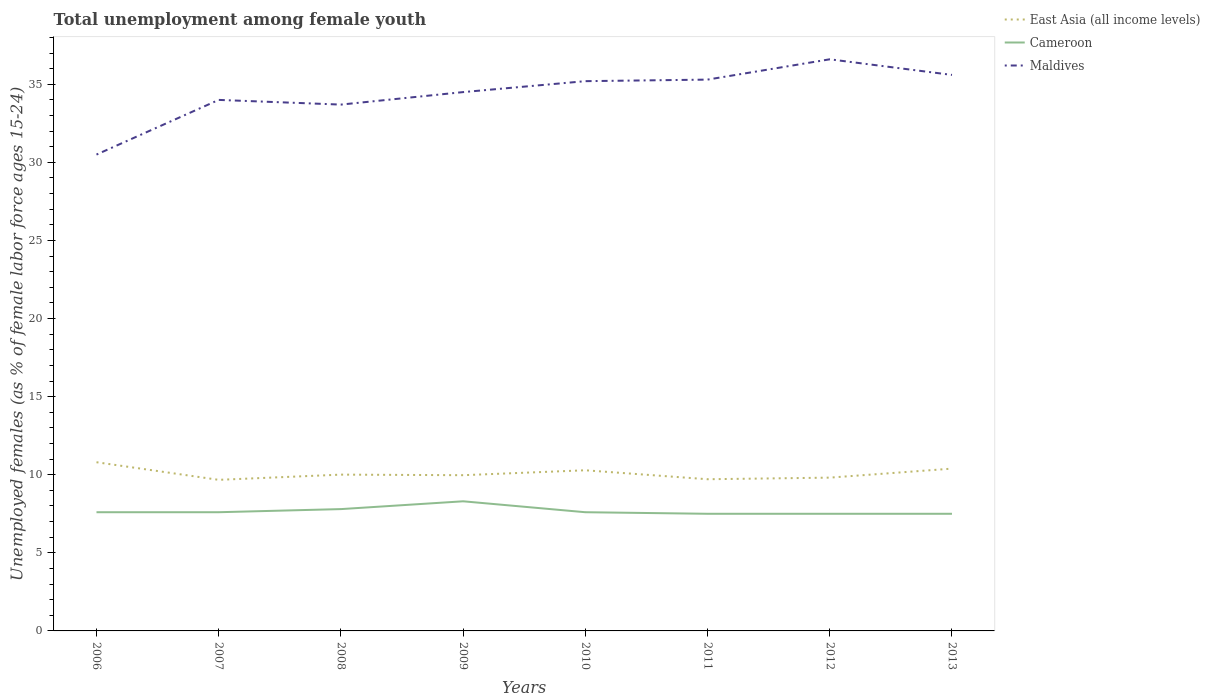How many different coloured lines are there?
Provide a short and direct response. 3. Across all years, what is the maximum percentage of unemployed females in in Cameroon?
Provide a succinct answer. 7.5. What is the total percentage of unemployed females in in Cameroon in the graph?
Offer a very short reply. 0.3. What is the difference between the highest and the second highest percentage of unemployed females in in Cameroon?
Your response must be concise. 0.8. Is the percentage of unemployed females in in Maldives strictly greater than the percentage of unemployed females in in East Asia (all income levels) over the years?
Your answer should be very brief. No. How many years are there in the graph?
Provide a succinct answer. 8. Are the values on the major ticks of Y-axis written in scientific E-notation?
Offer a very short reply. No. Does the graph contain grids?
Your response must be concise. No. Where does the legend appear in the graph?
Your response must be concise. Top right. What is the title of the graph?
Give a very brief answer. Total unemployment among female youth. What is the label or title of the X-axis?
Make the answer very short. Years. What is the label or title of the Y-axis?
Provide a short and direct response. Unemployed females (as % of female labor force ages 15-24). What is the Unemployed females (as % of female labor force ages 15-24) in East Asia (all income levels) in 2006?
Provide a succinct answer. 10.8. What is the Unemployed females (as % of female labor force ages 15-24) in Cameroon in 2006?
Ensure brevity in your answer.  7.6. What is the Unemployed females (as % of female labor force ages 15-24) of Maldives in 2006?
Provide a succinct answer. 30.5. What is the Unemployed females (as % of female labor force ages 15-24) in East Asia (all income levels) in 2007?
Keep it short and to the point. 9.67. What is the Unemployed females (as % of female labor force ages 15-24) of Cameroon in 2007?
Your answer should be very brief. 7.6. What is the Unemployed females (as % of female labor force ages 15-24) in East Asia (all income levels) in 2008?
Make the answer very short. 10.01. What is the Unemployed females (as % of female labor force ages 15-24) of Cameroon in 2008?
Give a very brief answer. 7.8. What is the Unemployed females (as % of female labor force ages 15-24) of Maldives in 2008?
Your response must be concise. 33.7. What is the Unemployed females (as % of female labor force ages 15-24) of East Asia (all income levels) in 2009?
Keep it short and to the point. 9.97. What is the Unemployed females (as % of female labor force ages 15-24) in Cameroon in 2009?
Offer a terse response. 8.3. What is the Unemployed females (as % of female labor force ages 15-24) of Maldives in 2009?
Make the answer very short. 34.5. What is the Unemployed females (as % of female labor force ages 15-24) in East Asia (all income levels) in 2010?
Offer a very short reply. 10.29. What is the Unemployed females (as % of female labor force ages 15-24) in Cameroon in 2010?
Ensure brevity in your answer.  7.6. What is the Unemployed females (as % of female labor force ages 15-24) of Maldives in 2010?
Your response must be concise. 35.2. What is the Unemployed females (as % of female labor force ages 15-24) of East Asia (all income levels) in 2011?
Give a very brief answer. 9.71. What is the Unemployed females (as % of female labor force ages 15-24) of Maldives in 2011?
Provide a short and direct response. 35.3. What is the Unemployed females (as % of female labor force ages 15-24) in East Asia (all income levels) in 2012?
Your response must be concise. 9.81. What is the Unemployed females (as % of female labor force ages 15-24) of Maldives in 2012?
Provide a short and direct response. 36.6. What is the Unemployed females (as % of female labor force ages 15-24) of East Asia (all income levels) in 2013?
Provide a short and direct response. 10.39. What is the Unemployed females (as % of female labor force ages 15-24) in Maldives in 2013?
Offer a very short reply. 35.6. Across all years, what is the maximum Unemployed females (as % of female labor force ages 15-24) of East Asia (all income levels)?
Provide a succinct answer. 10.8. Across all years, what is the maximum Unemployed females (as % of female labor force ages 15-24) of Cameroon?
Ensure brevity in your answer.  8.3. Across all years, what is the maximum Unemployed females (as % of female labor force ages 15-24) in Maldives?
Offer a terse response. 36.6. Across all years, what is the minimum Unemployed females (as % of female labor force ages 15-24) in East Asia (all income levels)?
Offer a very short reply. 9.67. Across all years, what is the minimum Unemployed females (as % of female labor force ages 15-24) in Maldives?
Make the answer very short. 30.5. What is the total Unemployed females (as % of female labor force ages 15-24) of East Asia (all income levels) in the graph?
Your answer should be very brief. 80.66. What is the total Unemployed females (as % of female labor force ages 15-24) of Cameroon in the graph?
Keep it short and to the point. 61.4. What is the total Unemployed females (as % of female labor force ages 15-24) of Maldives in the graph?
Offer a very short reply. 275.4. What is the difference between the Unemployed females (as % of female labor force ages 15-24) of East Asia (all income levels) in 2006 and that in 2007?
Offer a very short reply. 1.13. What is the difference between the Unemployed females (as % of female labor force ages 15-24) in Cameroon in 2006 and that in 2007?
Give a very brief answer. 0. What is the difference between the Unemployed females (as % of female labor force ages 15-24) of Maldives in 2006 and that in 2007?
Offer a terse response. -3.5. What is the difference between the Unemployed females (as % of female labor force ages 15-24) in East Asia (all income levels) in 2006 and that in 2008?
Ensure brevity in your answer.  0.79. What is the difference between the Unemployed females (as % of female labor force ages 15-24) of Cameroon in 2006 and that in 2008?
Provide a short and direct response. -0.2. What is the difference between the Unemployed females (as % of female labor force ages 15-24) of East Asia (all income levels) in 2006 and that in 2009?
Your response must be concise. 0.83. What is the difference between the Unemployed females (as % of female labor force ages 15-24) of Cameroon in 2006 and that in 2009?
Keep it short and to the point. -0.7. What is the difference between the Unemployed females (as % of female labor force ages 15-24) in Maldives in 2006 and that in 2009?
Ensure brevity in your answer.  -4. What is the difference between the Unemployed females (as % of female labor force ages 15-24) of East Asia (all income levels) in 2006 and that in 2010?
Your answer should be very brief. 0.51. What is the difference between the Unemployed females (as % of female labor force ages 15-24) of East Asia (all income levels) in 2006 and that in 2011?
Ensure brevity in your answer.  1.09. What is the difference between the Unemployed females (as % of female labor force ages 15-24) in Cameroon in 2006 and that in 2011?
Ensure brevity in your answer.  0.1. What is the difference between the Unemployed females (as % of female labor force ages 15-24) of Maldives in 2006 and that in 2011?
Offer a terse response. -4.8. What is the difference between the Unemployed females (as % of female labor force ages 15-24) of Cameroon in 2006 and that in 2012?
Provide a succinct answer. 0.1. What is the difference between the Unemployed females (as % of female labor force ages 15-24) of Maldives in 2006 and that in 2012?
Offer a very short reply. -6.1. What is the difference between the Unemployed females (as % of female labor force ages 15-24) of East Asia (all income levels) in 2006 and that in 2013?
Make the answer very short. 0.41. What is the difference between the Unemployed females (as % of female labor force ages 15-24) in Cameroon in 2006 and that in 2013?
Make the answer very short. 0.1. What is the difference between the Unemployed females (as % of female labor force ages 15-24) in East Asia (all income levels) in 2007 and that in 2008?
Offer a very short reply. -0.33. What is the difference between the Unemployed females (as % of female labor force ages 15-24) of Maldives in 2007 and that in 2008?
Provide a succinct answer. 0.3. What is the difference between the Unemployed females (as % of female labor force ages 15-24) of East Asia (all income levels) in 2007 and that in 2009?
Give a very brief answer. -0.3. What is the difference between the Unemployed females (as % of female labor force ages 15-24) in Cameroon in 2007 and that in 2009?
Ensure brevity in your answer.  -0.7. What is the difference between the Unemployed females (as % of female labor force ages 15-24) of East Asia (all income levels) in 2007 and that in 2010?
Make the answer very short. -0.61. What is the difference between the Unemployed females (as % of female labor force ages 15-24) of Cameroon in 2007 and that in 2010?
Offer a very short reply. 0. What is the difference between the Unemployed females (as % of female labor force ages 15-24) of Maldives in 2007 and that in 2010?
Make the answer very short. -1.2. What is the difference between the Unemployed females (as % of female labor force ages 15-24) of East Asia (all income levels) in 2007 and that in 2011?
Provide a short and direct response. -0.04. What is the difference between the Unemployed females (as % of female labor force ages 15-24) in Cameroon in 2007 and that in 2011?
Give a very brief answer. 0.1. What is the difference between the Unemployed females (as % of female labor force ages 15-24) in East Asia (all income levels) in 2007 and that in 2012?
Offer a very short reply. -0.14. What is the difference between the Unemployed females (as % of female labor force ages 15-24) of Maldives in 2007 and that in 2012?
Your answer should be compact. -2.6. What is the difference between the Unemployed females (as % of female labor force ages 15-24) of East Asia (all income levels) in 2007 and that in 2013?
Ensure brevity in your answer.  -0.72. What is the difference between the Unemployed females (as % of female labor force ages 15-24) in Maldives in 2007 and that in 2013?
Your answer should be very brief. -1.6. What is the difference between the Unemployed females (as % of female labor force ages 15-24) of East Asia (all income levels) in 2008 and that in 2009?
Make the answer very short. 0.04. What is the difference between the Unemployed females (as % of female labor force ages 15-24) in Maldives in 2008 and that in 2009?
Give a very brief answer. -0.8. What is the difference between the Unemployed females (as % of female labor force ages 15-24) in East Asia (all income levels) in 2008 and that in 2010?
Your answer should be compact. -0.28. What is the difference between the Unemployed females (as % of female labor force ages 15-24) of East Asia (all income levels) in 2008 and that in 2011?
Make the answer very short. 0.3. What is the difference between the Unemployed females (as % of female labor force ages 15-24) of Maldives in 2008 and that in 2011?
Your answer should be compact. -1.6. What is the difference between the Unemployed females (as % of female labor force ages 15-24) of East Asia (all income levels) in 2008 and that in 2012?
Provide a succinct answer. 0.19. What is the difference between the Unemployed females (as % of female labor force ages 15-24) of Cameroon in 2008 and that in 2012?
Offer a very short reply. 0.3. What is the difference between the Unemployed females (as % of female labor force ages 15-24) of Maldives in 2008 and that in 2012?
Ensure brevity in your answer.  -2.9. What is the difference between the Unemployed females (as % of female labor force ages 15-24) in East Asia (all income levels) in 2008 and that in 2013?
Keep it short and to the point. -0.38. What is the difference between the Unemployed females (as % of female labor force ages 15-24) of East Asia (all income levels) in 2009 and that in 2010?
Keep it short and to the point. -0.32. What is the difference between the Unemployed females (as % of female labor force ages 15-24) of Cameroon in 2009 and that in 2010?
Your answer should be very brief. 0.7. What is the difference between the Unemployed females (as % of female labor force ages 15-24) of East Asia (all income levels) in 2009 and that in 2011?
Ensure brevity in your answer.  0.26. What is the difference between the Unemployed females (as % of female labor force ages 15-24) of Maldives in 2009 and that in 2011?
Ensure brevity in your answer.  -0.8. What is the difference between the Unemployed females (as % of female labor force ages 15-24) in East Asia (all income levels) in 2009 and that in 2012?
Your answer should be very brief. 0.16. What is the difference between the Unemployed females (as % of female labor force ages 15-24) of Cameroon in 2009 and that in 2012?
Provide a succinct answer. 0.8. What is the difference between the Unemployed females (as % of female labor force ages 15-24) in East Asia (all income levels) in 2009 and that in 2013?
Keep it short and to the point. -0.42. What is the difference between the Unemployed females (as % of female labor force ages 15-24) of Cameroon in 2009 and that in 2013?
Your answer should be compact. 0.8. What is the difference between the Unemployed females (as % of female labor force ages 15-24) in East Asia (all income levels) in 2010 and that in 2011?
Provide a short and direct response. 0.57. What is the difference between the Unemployed females (as % of female labor force ages 15-24) of Cameroon in 2010 and that in 2011?
Your answer should be compact. 0.1. What is the difference between the Unemployed females (as % of female labor force ages 15-24) of Maldives in 2010 and that in 2011?
Your response must be concise. -0.1. What is the difference between the Unemployed females (as % of female labor force ages 15-24) of East Asia (all income levels) in 2010 and that in 2012?
Provide a succinct answer. 0.47. What is the difference between the Unemployed females (as % of female labor force ages 15-24) in Cameroon in 2010 and that in 2012?
Offer a terse response. 0.1. What is the difference between the Unemployed females (as % of female labor force ages 15-24) in Maldives in 2010 and that in 2012?
Ensure brevity in your answer.  -1.4. What is the difference between the Unemployed females (as % of female labor force ages 15-24) of East Asia (all income levels) in 2010 and that in 2013?
Your answer should be compact. -0.11. What is the difference between the Unemployed females (as % of female labor force ages 15-24) of Cameroon in 2010 and that in 2013?
Your answer should be very brief. 0.1. What is the difference between the Unemployed females (as % of female labor force ages 15-24) in Maldives in 2010 and that in 2013?
Give a very brief answer. -0.4. What is the difference between the Unemployed females (as % of female labor force ages 15-24) in East Asia (all income levels) in 2011 and that in 2012?
Make the answer very short. -0.1. What is the difference between the Unemployed females (as % of female labor force ages 15-24) in Cameroon in 2011 and that in 2012?
Your answer should be compact. 0. What is the difference between the Unemployed females (as % of female labor force ages 15-24) in East Asia (all income levels) in 2011 and that in 2013?
Provide a succinct answer. -0.68. What is the difference between the Unemployed females (as % of female labor force ages 15-24) of East Asia (all income levels) in 2012 and that in 2013?
Provide a short and direct response. -0.58. What is the difference between the Unemployed females (as % of female labor force ages 15-24) in Cameroon in 2012 and that in 2013?
Ensure brevity in your answer.  0. What is the difference between the Unemployed females (as % of female labor force ages 15-24) of Maldives in 2012 and that in 2013?
Give a very brief answer. 1. What is the difference between the Unemployed females (as % of female labor force ages 15-24) in East Asia (all income levels) in 2006 and the Unemployed females (as % of female labor force ages 15-24) in Cameroon in 2007?
Ensure brevity in your answer.  3.2. What is the difference between the Unemployed females (as % of female labor force ages 15-24) in East Asia (all income levels) in 2006 and the Unemployed females (as % of female labor force ages 15-24) in Maldives in 2007?
Provide a succinct answer. -23.2. What is the difference between the Unemployed females (as % of female labor force ages 15-24) of Cameroon in 2006 and the Unemployed females (as % of female labor force ages 15-24) of Maldives in 2007?
Make the answer very short. -26.4. What is the difference between the Unemployed females (as % of female labor force ages 15-24) of East Asia (all income levels) in 2006 and the Unemployed females (as % of female labor force ages 15-24) of Cameroon in 2008?
Provide a succinct answer. 3. What is the difference between the Unemployed females (as % of female labor force ages 15-24) of East Asia (all income levels) in 2006 and the Unemployed females (as % of female labor force ages 15-24) of Maldives in 2008?
Provide a short and direct response. -22.9. What is the difference between the Unemployed females (as % of female labor force ages 15-24) of Cameroon in 2006 and the Unemployed females (as % of female labor force ages 15-24) of Maldives in 2008?
Your answer should be compact. -26.1. What is the difference between the Unemployed females (as % of female labor force ages 15-24) of East Asia (all income levels) in 2006 and the Unemployed females (as % of female labor force ages 15-24) of Cameroon in 2009?
Make the answer very short. 2.5. What is the difference between the Unemployed females (as % of female labor force ages 15-24) in East Asia (all income levels) in 2006 and the Unemployed females (as % of female labor force ages 15-24) in Maldives in 2009?
Your response must be concise. -23.7. What is the difference between the Unemployed females (as % of female labor force ages 15-24) in Cameroon in 2006 and the Unemployed females (as % of female labor force ages 15-24) in Maldives in 2009?
Provide a short and direct response. -26.9. What is the difference between the Unemployed females (as % of female labor force ages 15-24) in East Asia (all income levels) in 2006 and the Unemployed females (as % of female labor force ages 15-24) in Cameroon in 2010?
Keep it short and to the point. 3.2. What is the difference between the Unemployed females (as % of female labor force ages 15-24) in East Asia (all income levels) in 2006 and the Unemployed females (as % of female labor force ages 15-24) in Maldives in 2010?
Give a very brief answer. -24.4. What is the difference between the Unemployed females (as % of female labor force ages 15-24) in Cameroon in 2006 and the Unemployed females (as % of female labor force ages 15-24) in Maldives in 2010?
Provide a succinct answer. -27.6. What is the difference between the Unemployed females (as % of female labor force ages 15-24) of East Asia (all income levels) in 2006 and the Unemployed females (as % of female labor force ages 15-24) of Cameroon in 2011?
Give a very brief answer. 3.3. What is the difference between the Unemployed females (as % of female labor force ages 15-24) in East Asia (all income levels) in 2006 and the Unemployed females (as % of female labor force ages 15-24) in Maldives in 2011?
Your response must be concise. -24.5. What is the difference between the Unemployed females (as % of female labor force ages 15-24) of Cameroon in 2006 and the Unemployed females (as % of female labor force ages 15-24) of Maldives in 2011?
Offer a terse response. -27.7. What is the difference between the Unemployed females (as % of female labor force ages 15-24) in East Asia (all income levels) in 2006 and the Unemployed females (as % of female labor force ages 15-24) in Cameroon in 2012?
Ensure brevity in your answer.  3.3. What is the difference between the Unemployed females (as % of female labor force ages 15-24) in East Asia (all income levels) in 2006 and the Unemployed females (as % of female labor force ages 15-24) in Maldives in 2012?
Your response must be concise. -25.8. What is the difference between the Unemployed females (as % of female labor force ages 15-24) in Cameroon in 2006 and the Unemployed females (as % of female labor force ages 15-24) in Maldives in 2012?
Your response must be concise. -29. What is the difference between the Unemployed females (as % of female labor force ages 15-24) in East Asia (all income levels) in 2006 and the Unemployed females (as % of female labor force ages 15-24) in Cameroon in 2013?
Provide a succinct answer. 3.3. What is the difference between the Unemployed females (as % of female labor force ages 15-24) of East Asia (all income levels) in 2006 and the Unemployed females (as % of female labor force ages 15-24) of Maldives in 2013?
Your answer should be compact. -24.8. What is the difference between the Unemployed females (as % of female labor force ages 15-24) in Cameroon in 2006 and the Unemployed females (as % of female labor force ages 15-24) in Maldives in 2013?
Offer a terse response. -28. What is the difference between the Unemployed females (as % of female labor force ages 15-24) of East Asia (all income levels) in 2007 and the Unemployed females (as % of female labor force ages 15-24) of Cameroon in 2008?
Offer a terse response. 1.87. What is the difference between the Unemployed females (as % of female labor force ages 15-24) of East Asia (all income levels) in 2007 and the Unemployed females (as % of female labor force ages 15-24) of Maldives in 2008?
Your answer should be very brief. -24.03. What is the difference between the Unemployed females (as % of female labor force ages 15-24) of Cameroon in 2007 and the Unemployed females (as % of female labor force ages 15-24) of Maldives in 2008?
Offer a very short reply. -26.1. What is the difference between the Unemployed females (as % of female labor force ages 15-24) of East Asia (all income levels) in 2007 and the Unemployed females (as % of female labor force ages 15-24) of Cameroon in 2009?
Offer a very short reply. 1.37. What is the difference between the Unemployed females (as % of female labor force ages 15-24) of East Asia (all income levels) in 2007 and the Unemployed females (as % of female labor force ages 15-24) of Maldives in 2009?
Give a very brief answer. -24.83. What is the difference between the Unemployed females (as % of female labor force ages 15-24) in Cameroon in 2007 and the Unemployed females (as % of female labor force ages 15-24) in Maldives in 2009?
Keep it short and to the point. -26.9. What is the difference between the Unemployed females (as % of female labor force ages 15-24) in East Asia (all income levels) in 2007 and the Unemployed females (as % of female labor force ages 15-24) in Cameroon in 2010?
Keep it short and to the point. 2.07. What is the difference between the Unemployed females (as % of female labor force ages 15-24) of East Asia (all income levels) in 2007 and the Unemployed females (as % of female labor force ages 15-24) of Maldives in 2010?
Make the answer very short. -25.53. What is the difference between the Unemployed females (as % of female labor force ages 15-24) of Cameroon in 2007 and the Unemployed females (as % of female labor force ages 15-24) of Maldives in 2010?
Your answer should be very brief. -27.6. What is the difference between the Unemployed females (as % of female labor force ages 15-24) of East Asia (all income levels) in 2007 and the Unemployed females (as % of female labor force ages 15-24) of Cameroon in 2011?
Your response must be concise. 2.17. What is the difference between the Unemployed females (as % of female labor force ages 15-24) in East Asia (all income levels) in 2007 and the Unemployed females (as % of female labor force ages 15-24) in Maldives in 2011?
Your response must be concise. -25.63. What is the difference between the Unemployed females (as % of female labor force ages 15-24) in Cameroon in 2007 and the Unemployed females (as % of female labor force ages 15-24) in Maldives in 2011?
Your answer should be very brief. -27.7. What is the difference between the Unemployed females (as % of female labor force ages 15-24) of East Asia (all income levels) in 2007 and the Unemployed females (as % of female labor force ages 15-24) of Cameroon in 2012?
Provide a succinct answer. 2.17. What is the difference between the Unemployed females (as % of female labor force ages 15-24) of East Asia (all income levels) in 2007 and the Unemployed females (as % of female labor force ages 15-24) of Maldives in 2012?
Offer a very short reply. -26.93. What is the difference between the Unemployed females (as % of female labor force ages 15-24) in Cameroon in 2007 and the Unemployed females (as % of female labor force ages 15-24) in Maldives in 2012?
Make the answer very short. -29. What is the difference between the Unemployed females (as % of female labor force ages 15-24) of East Asia (all income levels) in 2007 and the Unemployed females (as % of female labor force ages 15-24) of Cameroon in 2013?
Provide a short and direct response. 2.17. What is the difference between the Unemployed females (as % of female labor force ages 15-24) of East Asia (all income levels) in 2007 and the Unemployed females (as % of female labor force ages 15-24) of Maldives in 2013?
Offer a very short reply. -25.93. What is the difference between the Unemployed females (as % of female labor force ages 15-24) in East Asia (all income levels) in 2008 and the Unemployed females (as % of female labor force ages 15-24) in Cameroon in 2009?
Offer a very short reply. 1.71. What is the difference between the Unemployed females (as % of female labor force ages 15-24) in East Asia (all income levels) in 2008 and the Unemployed females (as % of female labor force ages 15-24) in Maldives in 2009?
Your answer should be very brief. -24.49. What is the difference between the Unemployed females (as % of female labor force ages 15-24) in Cameroon in 2008 and the Unemployed females (as % of female labor force ages 15-24) in Maldives in 2009?
Offer a terse response. -26.7. What is the difference between the Unemployed females (as % of female labor force ages 15-24) in East Asia (all income levels) in 2008 and the Unemployed females (as % of female labor force ages 15-24) in Cameroon in 2010?
Provide a short and direct response. 2.41. What is the difference between the Unemployed females (as % of female labor force ages 15-24) in East Asia (all income levels) in 2008 and the Unemployed females (as % of female labor force ages 15-24) in Maldives in 2010?
Your answer should be compact. -25.19. What is the difference between the Unemployed females (as % of female labor force ages 15-24) of Cameroon in 2008 and the Unemployed females (as % of female labor force ages 15-24) of Maldives in 2010?
Provide a short and direct response. -27.4. What is the difference between the Unemployed females (as % of female labor force ages 15-24) in East Asia (all income levels) in 2008 and the Unemployed females (as % of female labor force ages 15-24) in Cameroon in 2011?
Provide a short and direct response. 2.51. What is the difference between the Unemployed females (as % of female labor force ages 15-24) of East Asia (all income levels) in 2008 and the Unemployed females (as % of female labor force ages 15-24) of Maldives in 2011?
Provide a succinct answer. -25.29. What is the difference between the Unemployed females (as % of female labor force ages 15-24) in Cameroon in 2008 and the Unemployed females (as % of female labor force ages 15-24) in Maldives in 2011?
Make the answer very short. -27.5. What is the difference between the Unemployed females (as % of female labor force ages 15-24) of East Asia (all income levels) in 2008 and the Unemployed females (as % of female labor force ages 15-24) of Cameroon in 2012?
Provide a short and direct response. 2.51. What is the difference between the Unemployed females (as % of female labor force ages 15-24) in East Asia (all income levels) in 2008 and the Unemployed females (as % of female labor force ages 15-24) in Maldives in 2012?
Your answer should be compact. -26.59. What is the difference between the Unemployed females (as % of female labor force ages 15-24) in Cameroon in 2008 and the Unemployed females (as % of female labor force ages 15-24) in Maldives in 2012?
Provide a short and direct response. -28.8. What is the difference between the Unemployed females (as % of female labor force ages 15-24) in East Asia (all income levels) in 2008 and the Unemployed females (as % of female labor force ages 15-24) in Cameroon in 2013?
Keep it short and to the point. 2.51. What is the difference between the Unemployed females (as % of female labor force ages 15-24) of East Asia (all income levels) in 2008 and the Unemployed females (as % of female labor force ages 15-24) of Maldives in 2013?
Your answer should be compact. -25.59. What is the difference between the Unemployed females (as % of female labor force ages 15-24) of Cameroon in 2008 and the Unemployed females (as % of female labor force ages 15-24) of Maldives in 2013?
Provide a succinct answer. -27.8. What is the difference between the Unemployed females (as % of female labor force ages 15-24) of East Asia (all income levels) in 2009 and the Unemployed females (as % of female labor force ages 15-24) of Cameroon in 2010?
Your answer should be very brief. 2.37. What is the difference between the Unemployed females (as % of female labor force ages 15-24) of East Asia (all income levels) in 2009 and the Unemployed females (as % of female labor force ages 15-24) of Maldives in 2010?
Give a very brief answer. -25.23. What is the difference between the Unemployed females (as % of female labor force ages 15-24) of Cameroon in 2009 and the Unemployed females (as % of female labor force ages 15-24) of Maldives in 2010?
Provide a succinct answer. -26.9. What is the difference between the Unemployed females (as % of female labor force ages 15-24) in East Asia (all income levels) in 2009 and the Unemployed females (as % of female labor force ages 15-24) in Cameroon in 2011?
Make the answer very short. 2.47. What is the difference between the Unemployed females (as % of female labor force ages 15-24) in East Asia (all income levels) in 2009 and the Unemployed females (as % of female labor force ages 15-24) in Maldives in 2011?
Make the answer very short. -25.33. What is the difference between the Unemployed females (as % of female labor force ages 15-24) in East Asia (all income levels) in 2009 and the Unemployed females (as % of female labor force ages 15-24) in Cameroon in 2012?
Keep it short and to the point. 2.47. What is the difference between the Unemployed females (as % of female labor force ages 15-24) in East Asia (all income levels) in 2009 and the Unemployed females (as % of female labor force ages 15-24) in Maldives in 2012?
Make the answer very short. -26.63. What is the difference between the Unemployed females (as % of female labor force ages 15-24) in Cameroon in 2009 and the Unemployed females (as % of female labor force ages 15-24) in Maldives in 2012?
Offer a terse response. -28.3. What is the difference between the Unemployed females (as % of female labor force ages 15-24) in East Asia (all income levels) in 2009 and the Unemployed females (as % of female labor force ages 15-24) in Cameroon in 2013?
Your answer should be compact. 2.47. What is the difference between the Unemployed females (as % of female labor force ages 15-24) in East Asia (all income levels) in 2009 and the Unemployed females (as % of female labor force ages 15-24) in Maldives in 2013?
Provide a succinct answer. -25.63. What is the difference between the Unemployed females (as % of female labor force ages 15-24) in Cameroon in 2009 and the Unemployed females (as % of female labor force ages 15-24) in Maldives in 2013?
Your answer should be very brief. -27.3. What is the difference between the Unemployed females (as % of female labor force ages 15-24) in East Asia (all income levels) in 2010 and the Unemployed females (as % of female labor force ages 15-24) in Cameroon in 2011?
Make the answer very short. 2.79. What is the difference between the Unemployed females (as % of female labor force ages 15-24) in East Asia (all income levels) in 2010 and the Unemployed females (as % of female labor force ages 15-24) in Maldives in 2011?
Your response must be concise. -25.01. What is the difference between the Unemployed females (as % of female labor force ages 15-24) of Cameroon in 2010 and the Unemployed females (as % of female labor force ages 15-24) of Maldives in 2011?
Your answer should be compact. -27.7. What is the difference between the Unemployed females (as % of female labor force ages 15-24) of East Asia (all income levels) in 2010 and the Unemployed females (as % of female labor force ages 15-24) of Cameroon in 2012?
Provide a short and direct response. 2.79. What is the difference between the Unemployed females (as % of female labor force ages 15-24) of East Asia (all income levels) in 2010 and the Unemployed females (as % of female labor force ages 15-24) of Maldives in 2012?
Offer a terse response. -26.31. What is the difference between the Unemployed females (as % of female labor force ages 15-24) in East Asia (all income levels) in 2010 and the Unemployed females (as % of female labor force ages 15-24) in Cameroon in 2013?
Offer a very short reply. 2.79. What is the difference between the Unemployed females (as % of female labor force ages 15-24) in East Asia (all income levels) in 2010 and the Unemployed females (as % of female labor force ages 15-24) in Maldives in 2013?
Offer a terse response. -25.31. What is the difference between the Unemployed females (as % of female labor force ages 15-24) in Cameroon in 2010 and the Unemployed females (as % of female labor force ages 15-24) in Maldives in 2013?
Ensure brevity in your answer.  -28. What is the difference between the Unemployed females (as % of female labor force ages 15-24) of East Asia (all income levels) in 2011 and the Unemployed females (as % of female labor force ages 15-24) of Cameroon in 2012?
Offer a terse response. 2.21. What is the difference between the Unemployed females (as % of female labor force ages 15-24) of East Asia (all income levels) in 2011 and the Unemployed females (as % of female labor force ages 15-24) of Maldives in 2012?
Provide a short and direct response. -26.89. What is the difference between the Unemployed females (as % of female labor force ages 15-24) in Cameroon in 2011 and the Unemployed females (as % of female labor force ages 15-24) in Maldives in 2012?
Offer a very short reply. -29.1. What is the difference between the Unemployed females (as % of female labor force ages 15-24) of East Asia (all income levels) in 2011 and the Unemployed females (as % of female labor force ages 15-24) of Cameroon in 2013?
Your response must be concise. 2.21. What is the difference between the Unemployed females (as % of female labor force ages 15-24) in East Asia (all income levels) in 2011 and the Unemployed females (as % of female labor force ages 15-24) in Maldives in 2013?
Keep it short and to the point. -25.89. What is the difference between the Unemployed females (as % of female labor force ages 15-24) in Cameroon in 2011 and the Unemployed females (as % of female labor force ages 15-24) in Maldives in 2013?
Your answer should be very brief. -28.1. What is the difference between the Unemployed females (as % of female labor force ages 15-24) in East Asia (all income levels) in 2012 and the Unemployed females (as % of female labor force ages 15-24) in Cameroon in 2013?
Offer a terse response. 2.31. What is the difference between the Unemployed females (as % of female labor force ages 15-24) of East Asia (all income levels) in 2012 and the Unemployed females (as % of female labor force ages 15-24) of Maldives in 2013?
Ensure brevity in your answer.  -25.79. What is the difference between the Unemployed females (as % of female labor force ages 15-24) in Cameroon in 2012 and the Unemployed females (as % of female labor force ages 15-24) in Maldives in 2013?
Your response must be concise. -28.1. What is the average Unemployed females (as % of female labor force ages 15-24) in East Asia (all income levels) per year?
Your answer should be compact. 10.08. What is the average Unemployed females (as % of female labor force ages 15-24) in Cameroon per year?
Provide a short and direct response. 7.67. What is the average Unemployed females (as % of female labor force ages 15-24) of Maldives per year?
Your answer should be very brief. 34.42. In the year 2006, what is the difference between the Unemployed females (as % of female labor force ages 15-24) of East Asia (all income levels) and Unemployed females (as % of female labor force ages 15-24) of Cameroon?
Your answer should be compact. 3.2. In the year 2006, what is the difference between the Unemployed females (as % of female labor force ages 15-24) of East Asia (all income levels) and Unemployed females (as % of female labor force ages 15-24) of Maldives?
Your answer should be very brief. -19.7. In the year 2006, what is the difference between the Unemployed females (as % of female labor force ages 15-24) of Cameroon and Unemployed females (as % of female labor force ages 15-24) of Maldives?
Provide a short and direct response. -22.9. In the year 2007, what is the difference between the Unemployed females (as % of female labor force ages 15-24) of East Asia (all income levels) and Unemployed females (as % of female labor force ages 15-24) of Cameroon?
Your response must be concise. 2.07. In the year 2007, what is the difference between the Unemployed females (as % of female labor force ages 15-24) in East Asia (all income levels) and Unemployed females (as % of female labor force ages 15-24) in Maldives?
Offer a very short reply. -24.33. In the year 2007, what is the difference between the Unemployed females (as % of female labor force ages 15-24) of Cameroon and Unemployed females (as % of female labor force ages 15-24) of Maldives?
Your answer should be compact. -26.4. In the year 2008, what is the difference between the Unemployed females (as % of female labor force ages 15-24) in East Asia (all income levels) and Unemployed females (as % of female labor force ages 15-24) in Cameroon?
Offer a terse response. 2.21. In the year 2008, what is the difference between the Unemployed females (as % of female labor force ages 15-24) of East Asia (all income levels) and Unemployed females (as % of female labor force ages 15-24) of Maldives?
Your answer should be very brief. -23.69. In the year 2008, what is the difference between the Unemployed females (as % of female labor force ages 15-24) in Cameroon and Unemployed females (as % of female labor force ages 15-24) in Maldives?
Give a very brief answer. -25.9. In the year 2009, what is the difference between the Unemployed females (as % of female labor force ages 15-24) of East Asia (all income levels) and Unemployed females (as % of female labor force ages 15-24) of Cameroon?
Make the answer very short. 1.67. In the year 2009, what is the difference between the Unemployed females (as % of female labor force ages 15-24) in East Asia (all income levels) and Unemployed females (as % of female labor force ages 15-24) in Maldives?
Your answer should be compact. -24.53. In the year 2009, what is the difference between the Unemployed females (as % of female labor force ages 15-24) in Cameroon and Unemployed females (as % of female labor force ages 15-24) in Maldives?
Provide a short and direct response. -26.2. In the year 2010, what is the difference between the Unemployed females (as % of female labor force ages 15-24) in East Asia (all income levels) and Unemployed females (as % of female labor force ages 15-24) in Cameroon?
Your response must be concise. 2.69. In the year 2010, what is the difference between the Unemployed females (as % of female labor force ages 15-24) of East Asia (all income levels) and Unemployed females (as % of female labor force ages 15-24) of Maldives?
Keep it short and to the point. -24.91. In the year 2010, what is the difference between the Unemployed females (as % of female labor force ages 15-24) in Cameroon and Unemployed females (as % of female labor force ages 15-24) in Maldives?
Provide a short and direct response. -27.6. In the year 2011, what is the difference between the Unemployed females (as % of female labor force ages 15-24) of East Asia (all income levels) and Unemployed females (as % of female labor force ages 15-24) of Cameroon?
Your answer should be very brief. 2.21. In the year 2011, what is the difference between the Unemployed females (as % of female labor force ages 15-24) of East Asia (all income levels) and Unemployed females (as % of female labor force ages 15-24) of Maldives?
Your answer should be compact. -25.59. In the year 2011, what is the difference between the Unemployed females (as % of female labor force ages 15-24) of Cameroon and Unemployed females (as % of female labor force ages 15-24) of Maldives?
Provide a succinct answer. -27.8. In the year 2012, what is the difference between the Unemployed females (as % of female labor force ages 15-24) in East Asia (all income levels) and Unemployed females (as % of female labor force ages 15-24) in Cameroon?
Provide a short and direct response. 2.31. In the year 2012, what is the difference between the Unemployed females (as % of female labor force ages 15-24) in East Asia (all income levels) and Unemployed females (as % of female labor force ages 15-24) in Maldives?
Your answer should be very brief. -26.79. In the year 2012, what is the difference between the Unemployed females (as % of female labor force ages 15-24) in Cameroon and Unemployed females (as % of female labor force ages 15-24) in Maldives?
Give a very brief answer. -29.1. In the year 2013, what is the difference between the Unemployed females (as % of female labor force ages 15-24) in East Asia (all income levels) and Unemployed females (as % of female labor force ages 15-24) in Cameroon?
Provide a short and direct response. 2.89. In the year 2013, what is the difference between the Unemployed females (as % of female labor force ages 15-24) in East Asia (all income levels) and Unemployed females (as % of female labor force ages 15-24) in Maldives?
Offer a terse response. -25.21. In the year 2013, what is the difference between the Unemployed females (as % of female labor force ages 15-24) in Cameroon and Unemployed females (as % of female labor force ages 15-24) in Maldives?
Offer a very short reply. -28.1. What is the ratio of the Unemployed females (as % of female labor force ages 15-24) of East Asia (all income levels) in 2006 to that in 2007?
Ensure brevity in your answer.  1.12. What is the ratio of the Unemployed females (as % of female labor force ages 15-24) in Maldives in 2006 to that in 2007?
Ensure brevity in your answer.  0.9. What is the ratio of the Unemployed females (as % of female labor force ages 15-24) in East Asia (all income levels) in 2006 to that in 2008?
Ensure brevity in your answer.  1.08. What is the ratio of the Unemployed females (as % of female labor force ages 15-24) in Cameroon in 2006 to that in 2008?
Your answer should be compact. 0.97. What is the ratio of the Unemployed females (as % of female labor force ages 15-24) of Maldives in 2006 to that in 2008?
Ensure brevity in your answer.  0.91. What is the ratio of the Unemployed females (as % of female labor force ages 15-24) in East Asia (all income levels) in 2006 to that in 2009?
Your answer should be very brief. 1.08. What is the ratio of the Unemployed females (as % of female labor force ages 15-24) of Cameroon in 2006 to that in 2009?
Your answer should be very brief. 0.92. What is the ratio of the Unemployed females (as % of female labor force ages 15-24) of Maldives in 2006 to that in 2009?
Provide a succinct answer. 0.88. What is the ratio of the Unemployed females (as % of female labor force ages 15-24) of East Asia (all income levels) in 2006 to that in 2010?
Offer a terse response. 1.05. What is the ratio of the Unemployed females (as % of female labor force ages 15-24) in Maldives in 2006 to that in 2010?
Offer a very short reply. 0.87. What is the ratio of the Unemployed females (as % of female labor force ages 15-24) of East Asia (all income levels) in 2006 to that in 2011?
Offer a very short reply. 1.11. What is the ratio of the Unemployed females (as % of female labor force ages 15-24) in Cameroon in 2006 to that in 2011?
Your answer should be very brief. 1.01. What is the ratio of the Unemployed females (as % of female labor force ages 15-24) of Maldives in 2006 to that in 2011?
Your answer should be compact. 0.86. What is the ratio of the Unemployed females (as % of female labor force ages 15-24) in East Asia (all income levels) in 2006 to that in 2012?
Keep it short and to the point. 1.1. What is the ratio of the Unemployed females (as % of female labor force ages 15-24) in Cameroon in 2006 to that in 2012?
Your answer should be very brief. 1.01. What is the ratio of the Unemployed females (as % of female labor force ages 15-24) in East Asia (all income levels) in 2006 to that in 2013?
Provide a succinct answer. 1.04. What is the ratio of the Unemployed females (as % of female labor force ages 15-24) in Cameroon in 2006 to that in 2013?
Make the answer very short. 1.01. What is the ratio of the Unemployed females (as % of female labor force ages 15-24) in Maldives in 2006 to that in 2013?
Make the answer very short. 0.86. What is the ratio of the Unemployed females (as % of female labor force ages 15-24) in East Asia (all income levels) in 2007 to that in 2008?
Your answer should be compact. 0.97. What is the ratio of the Unemployed females (as % of female labor force ages 15-24) of Cameroon in 2007 to that in 2008?
Your answer should be very brief. 0.97. What is the ratio of the Unemployed females (as % of female labor force ages 15-24) in Maldives in 2007 to that in 2008?
Provide a succinct answer. 1.01. What is the ratio of the Unemployed females (as % of female labor force ages 15-24) of East Asia (all income levels) in 2007 to that in 2009?
Your answer should be compact. 0.97. What is the ratio of the Unemployed females (as % of female labor force ages 15-24) of Cameroon in 2007 to that in 2009?
Offer a terse response. 0.92. What is the ratio of the Unemployed females (as % of female labor force ages 15-24) in Maldives in 2007 to that in 2009?
Offer a very short reply. 0.99. What is the ratio of the Unemployed females (as % of female labor force ages 15-24) of East Asia (all income levels) in 2007 to that in 2010?
Your answer should be very brief. 0.94. What is the ratio of the Unemployed females (as % of female labor force ages 15-24) in Maldives in 2007 to that in 2010?
Ensure brevity in your answer.  0.97. What is the ratio of the Unemployed females (as % of female labor force ages 15-24) of East Asia (all income levels) in 2007 to that in 2011?
Offer a terse response. 1. What is the ratio of the Unemployed females (as % of female labor force ages 15-24) of Cameroon in 2007 to that in 2011?
Make the answer very short. 1.01. What is the ratio of the Unemployed females (as % of female labor force ages 15-24) of Maldives in 2007 to that in 2011?
Offer a very short reply. 0.96. What is the ratio of the Unemployed females (as % of female labor force ages 15-24) of East Asia (all income levels) in 2007 to that in 2012?
Make the answer very short. 0.99. What is the ratio of the Unemployed females (as % of female labor force ages 15-24) of Cameroon in 2007 to that in 2012?
Keep it short and to the point. 1.01. What is the ratio of the Unemployed females (as % of female labor force ages 15-24) of Maldives in 2007 to that in 2012?
Your answer should be compact. 0.93. What is the ratio of the Unemployed females (as % of female labor force ages 15-24) in East Asia (all income levels) in 2007 to that in 2013?
Offer a very short reply. 0.93. What is the ratio of the Unemployed females (as % of female labor force ages 15-24) of Cameroon in 2007 to that in 2013?
Make the answer very short. 1.01. What is the ratio of the Unemployed females (as % of female labor force ages 15-24) of Maldives in 2007 to that in 2013?
Provide a short and direct response. 0.96. What is the ratio of the Unemployed females (as % of female labor force ages 15-24) of Cameroon in 2008 to that in 2009?
Offer a terse response. 0.94. What is the ratio of the Unemployed females (as % of female labor force ages 15-24) in Maldives in 2008 to that in 2009?
Keep it short and to the point. 0.98. What is the ratio of the Unemployed females (as % of female labor force ages 15-24) of East Asia (all income levels) in 2008 to that in 2010?
Your answer should be very brief. 0.97. What is the ratio of the Unemployed females (as % of female labor force ages 15-24) in Cameroon in 2008 to that in 2010?
Offer a very short reply. 1.03. What is the ratio of the Unemployed females (as % of female labor force ages 15-24) of Maldives in 2008 to that in 2010?
Provide a succinct answer. 0.96. What is the ratio of the Unemployed females (as % of female labor force ages 15-24) of East Asia (all income levels) in 2008 to that in 2011?
Make the answer very short. 1.03. What is the ratio of the Unemployed females (as % of female labor force ages 15-24) in Cameroon in 2008 to that in 2011?
Provide a short and direct response. 1.04. What is the ratio of the Unemployed females (as % of female labor force ages 15-24) of Maldives in 2008 to that in 2011?
Keep it short and to the point. 0.95. What is the ratio of the Unemployed females (as % of female labor force ages 15-24) of East Asia (all income levels) in 2008 to that in 2012?
Keep it short and to the point. 1.02. What is the ratio of the Unemployed females (as % of female labor force ages 15-24) in Maldives in 2008 to that in 2012?
Ensure brevity in your answer.  0.92. What is the ratio of the Unemployed females (as % of female labor force ages 15-24) in Cameroon in 2008 to that in 2013?
Offer a terse response. 1.04. What is the ratio of the Unemployed females (as % of female labor force ages 15-24) of Maldives in 2008 to that in 2013?
Offer a very short reply. 0.95. What is the ratio of the Unemployed females (as % of female labor force ages 15-24) in East Asia (all income levels) in 2009 to that in 2010?
Your response must be concise. 0.97. What is the ratio of the Unemployed females (as % of female labor force ages 15-24) of Cameroon in 2009 to that in 2010?
Make the answer very short. 1.09. What is the ratio of the Unemployed females (as % of female labor force ages 15-24) of Maldives in 2009 to that in 2010?
Offer a terse response. 0.98. What is the ratio of the Unemployed females (as % of female labor force ages 15-24) of East Asia (all income levels) in 2009 to that in 2011?
Make the answer very short. 1.03. What is the ratio of the Unemployed females (as % of female labor force ages 15-24) in Cameroon in 2009 to that in 2011?
Offer a very short reply. 1.11. What is the ratio of the Unemployed females (as % of female labor force ages 15-24) of Maldives in 2009 to that in 2011?
Make the answer very short. 0.98. What is the ratio of the Unemployed females (as % of female labor force ages 15-24) of East Asia (all income levels) in 2009 to that in 2012?
Keep it short and to the point. 1.02. What is the ratio of the Unemployed females (as % of female labor force ages 15-24) in Cameroon in 2009 to that in 2012?
Ensure brevity in your answer.  1.11. What is the ratio of the Unemployed females (as % of female labor force ages 15-24) in Maldives in 2009 to that in 2012?
Give a very brief answer. 0.94. What is the ratio of the Unemployed females (as % of female labor force ages 15-24) of East Asia (all income levels) in 2009 to that in 2013?
Give a very brief answer. 0.96. What is the ratio of the Unemployed females (as % of female labor force ages 15-24) of Cameroon in 2009 to that in 2013?
Offer a terse response. 1.11. What is the ratio of the Unemployed females (as % of female labor force ages 15-24) in Maldives in 2009 to that in 2013?
Provide a succinct answer. 0.97. What is the ratio of the Unemployed females (as % of female labor force ages 15-24) in East Asia (all income levels) in 2010 to that in 2011?
Ensure brevity in your answer.  1.06. What is the ratio of the Unemployed females (as % of female labor force ages 15-24) of Cameroon in 2010 to that in 2011?
Offer a very short reply. 1.01. What is the ratio of the Unemployed females (as % of female labor force ages 15-24) in East Asia (all income levels) in 2010 to that in 2012?
Your answer should be compact. 1.05. What is the ratio of the Unemployed females (as % of female labor force ages 15-24) of Cameroon in 2010 to that in 2012?
Make the answer very short. 1.01. What is the ratio of the Unemployed females (as % of female labor force ages 15-24) of Maldives in 2010 to that in 2012?
Offer a terse response. 0.96. What is the ratio of the Unemployed females (as % of female labor force ages 15-24) of Cameroon in 2010 to that in 2013?
Give a very brief answer. 1.01. What is the ratio of the Unemployed females (as % of female labor force ages 15-24) of Cameroon in 2011 to that in 2012?
Ensure brevity in your answer.  1. What is the ratio of the Unemployed females (as % of female labor force ages 15-24) of Maldives in 2011 to that in 2012?
Provide a succinct answer. 0.96. What is the ratio of the Unemployed females (as % of female labor force ages 15-24) in East Asia (all income levels) in 2011 to that in 2013?
Your answer should be very brief. 0.93. What is the ratio of the Unemployed females (as % of female labor force ages 15-24) in East Asia (all income levels) in 2012 to that in 2013?
Provide a succinct answer. 0.94. What is the ratio of the Unemployed females (as % of female labor force ages 15-24) in Cameroon in 2012 to that in 2013?
Keep it short and to the point. 1. What is the ratio of the Unemployed females (as % of female labor force ages 15-24) in Maldives in 2012 to that in 2013?
Make the answer very short. 1.03. What is the difference between the highest and the second highest Unemployed females (as % of female labor force ages 15-24) of East Asia (all income levels)?
Give a very brief answer. 0.41. What is the difference between the highest and the second highest Unemployed females (as % of female labor force ages 15-24) of Maldives?
Keep it short and to the point. 1. What is the difference between the highest and the lowest Unemployed females (as % of female labor force ages 15-24) of East Asia (all income levels)?
Your answer should be compact. 1.13. What is the difference between the highest and the lowest Unemployed females (as % of female labor force ages 15-24) of Cameroon?
Give a very brief answer. 0.8. 